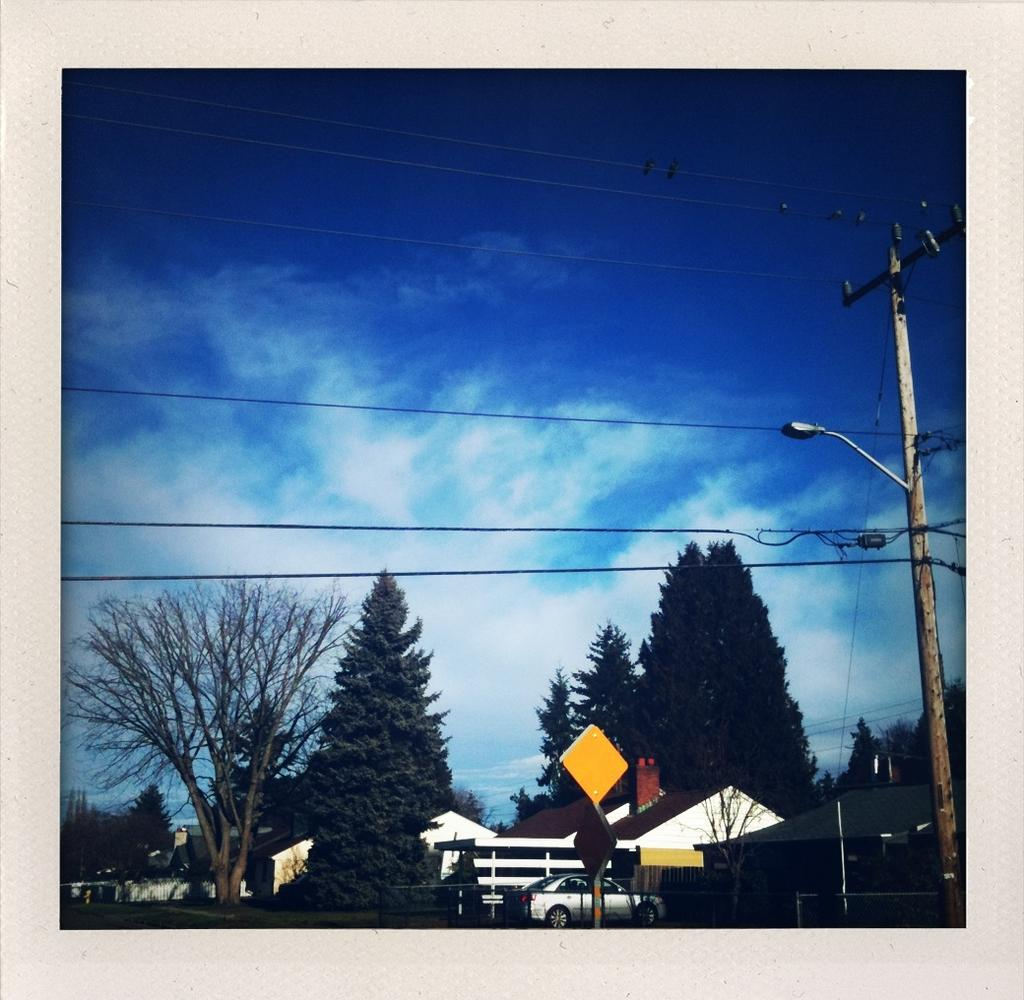What type of natural elements can be seen in the image? There are trees in the image. What man-made object is present on the ground in the image? There is a vehicle on the ground in the image. What structures are present in the image? There are poles, boards, wires, and buildings in the image. What is visible in the background of the image? The sky is visible in the background of the image. How many tramps are jumping on the trees in the image? There are no tramps present in the image, and trees are not meant for jumping. What type of clouds can be seen in the image? There is no mention of clouds in the provided facts, and the sky is only mentioned as being visible in the background. 